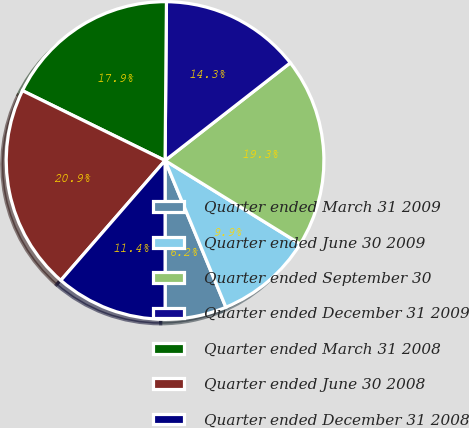<chart> <loc_0><loc_0><loc_500><loc_500><pie_chart><fcel>Quarter ended March 31 2009<fcel>Quarter ended June 30 2009<fcel>Quarter ended September 30<fcel>Quarter ended December 31 2009<fcel>Quarter ended March 31 2008<fcel>Quarter ended June 30 2008<fcel>Quarter ended December 31 2008<nl><fcel>6.25%<fcel>9.94%<fcel>19.35%<fcel>14.32%<fcel>17.89%<fcel>20.86%<fcel>11.4%<nl></chart> 